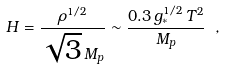<formula> <loc_0><loc_0><loc_500><loc_500>H = \frac { \rho ^ { 1 / 2 } } { \sqrt { 3 } \, M _ { p } } \sim \frac { 0 . 3 \, g _ { * } ^ { 1 / 2 } \, T ^ { 2 } } { M _ { p } } \ ,</formula> 